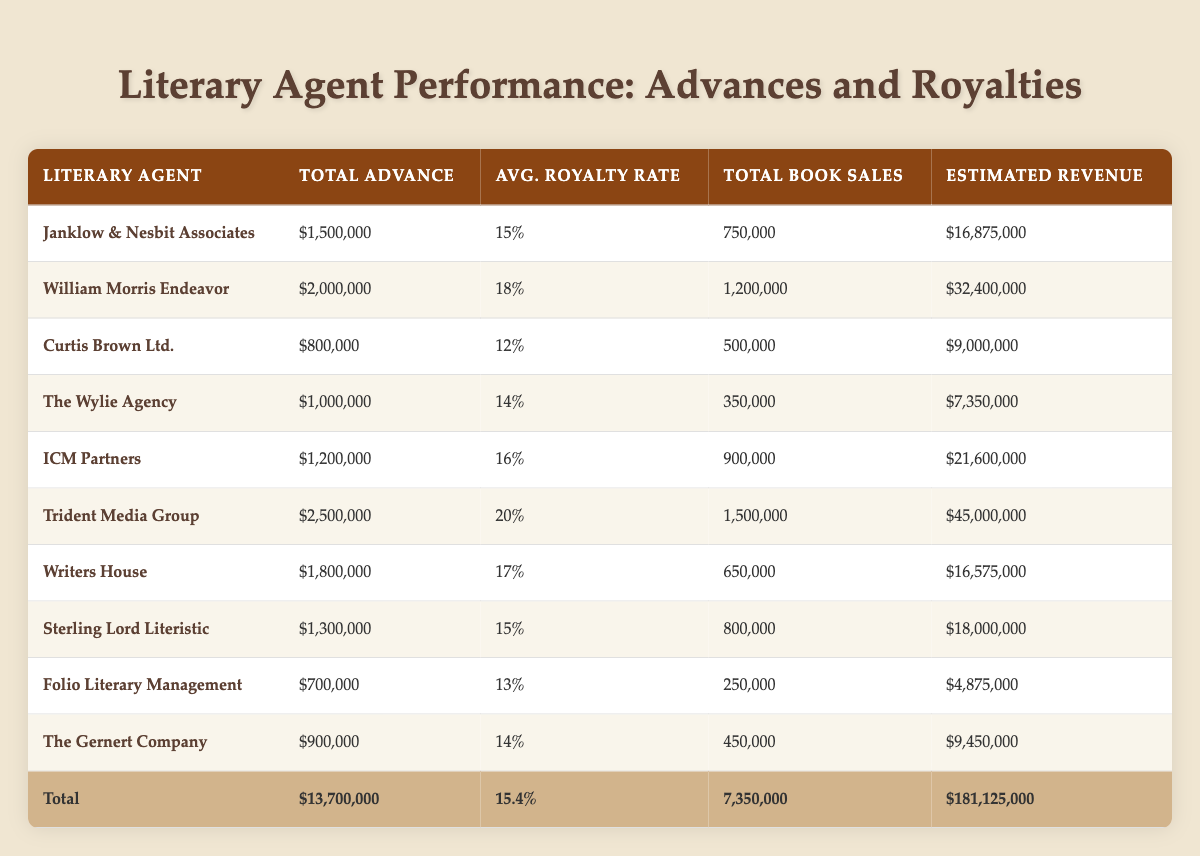What is the total advance amount represented by the agents in the table? To find the total advance, sum all the advance amounts presented for each literary agent: 1,500,000 + 2,000,000 + 800,000 + 1,000,000 + 1,200,000 + 2,500,000 + 1,800,000 + 1,300,000 + 700,000 + 900,000 = 13,700,000.
Answer: 13,700,000 Which agent has the highest average royalty rate? To identify the agent with the highest average royalty rate, compare the values listed for each agent. The highest value is 20% from Trident Media Group.
Answer: Trident Media Group Is the total book sales higher for William Morris Endeavor than for Writers House? The total book sales for William Morris Endeavor is 1,200,000 and for Writers House is 650,000. Since 1,200,000 is greater than 650,000, the statement is true.
Answer: Yes What is the estimated revenue for Curtis Brown Ltd.? The estimated revenue is directly stated in the table: it is calculated as the total book sales multiplied by the average royalty rate, which equals 500,000 * 12% = 9,000,000. This value is already given in the table.
Answer: 9,000,000 Which agent represents the author with the lowest advance? By reviewing the advance amounts, the lowest advance is 700,000, which is attributed to Folio Literary Management as per the data provided in the table.
Answer: Folio Literary Management What is the average advance amount across all agents? To get the average advance, sum all advances (1,500,000 + 2,000,000 + 800,000 + 1,000,000 + 1,200,000 + 2,500,000 + 1,800,000 + 1,300,000 + 700,000 + 900,000 = 13,700,000) and divide by the number of agents (10): 13,700,000 / 10 = 1,370,000.
Answer: 1,370,000 Which genres are represented by the agents who have total book sales above 1,000,000? By examining the total book sales, only William Morris Endeavor (Horror) and Trident Media Group (Legal Thriller) have book sales above 1,000,000, so the genres are Horror and Legal Thriller.
Answer: Horror and Legal Thriller What agent has a total advance amount below the average advance? The average advance is 1,370,000. The agents below this are Curtis Brown Ltd., Folio Literary Management, and The Gernert Company, as their total advances (800,000, 700,000, and 900,000, respectively) are all less than the average amount.
Answer: Curtis Brown Ltd., Folio Literary Management, The Gernert Company 